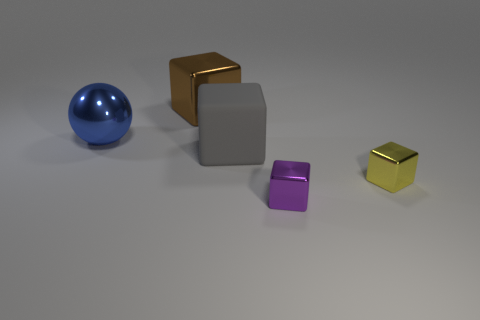What is the size of the thing that is both left of the tiny yellow object and in front of the rubber object?
Keep it short and to the point. Small. There is a large object behind the blue metallic thing; is it the same shape as the big blue object to the left of the rubber cube?
Your answer should be compact. No. What number of things are the same material as the blue sphere?
Provide a short and direct response. 3. There is a object that is both to the left of the purple object and to the right of the brown cube; what shape is it?
Give a very brief answer. Cube. Does the cube behind the large ball have the same material as the small purple block?
Make the answer very short. Yes. Is there any other thing that has the same material as the small yellow object?
Keep it short and to the point. Yes. There is another metal cube that is the same size as the yellow metal block; what is its color?
Offer a very short reply. Purple. Is there a small metal cube that has the same color as the rubber object?
Provide a succinct answer. No. What size is the brown cube that is the same material as the ball?
Make the answer very short. Large. How many other objects are there of the same size as the yellow block?
Make the answer very short. 1. 